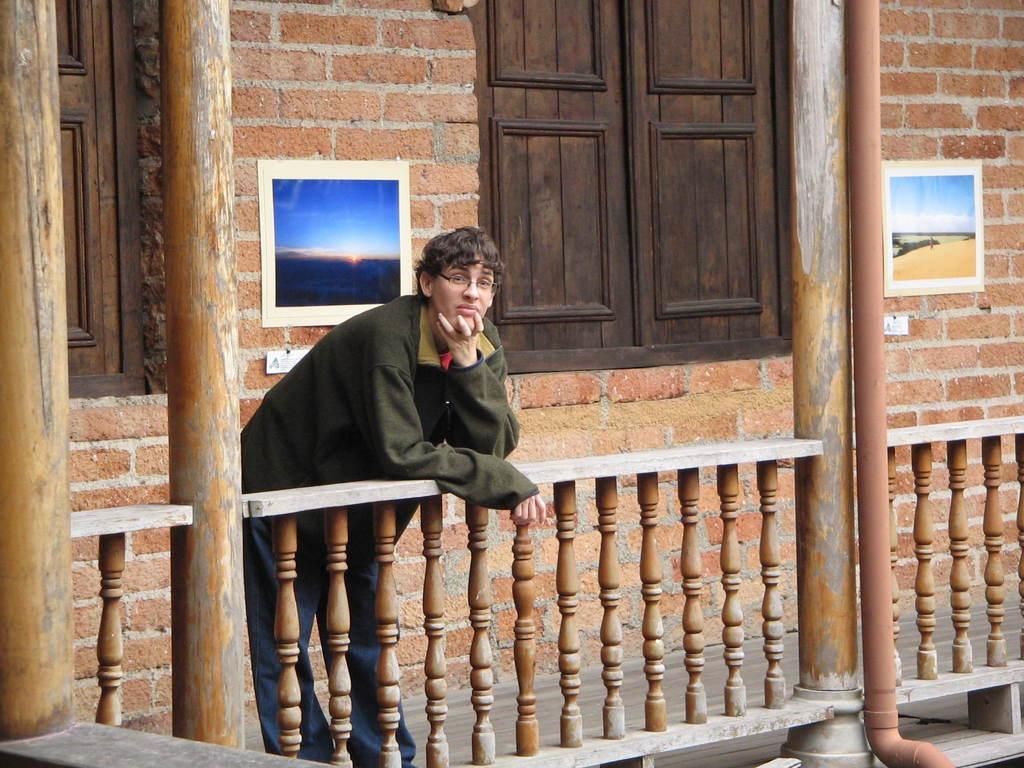Please provide a concise description of this image. In the foreground I can see a person is standing on the fence. In the background I can see a wall, windows, wall paintings and pillars. This image is taken during a day. 